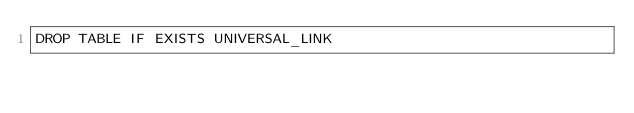Convert code to text. <code><loc_0><loc_0><loc_500><loc_500><_SQL_>DROP TABLE IF EXISTS UNIVERSAL_LINK
</code> 